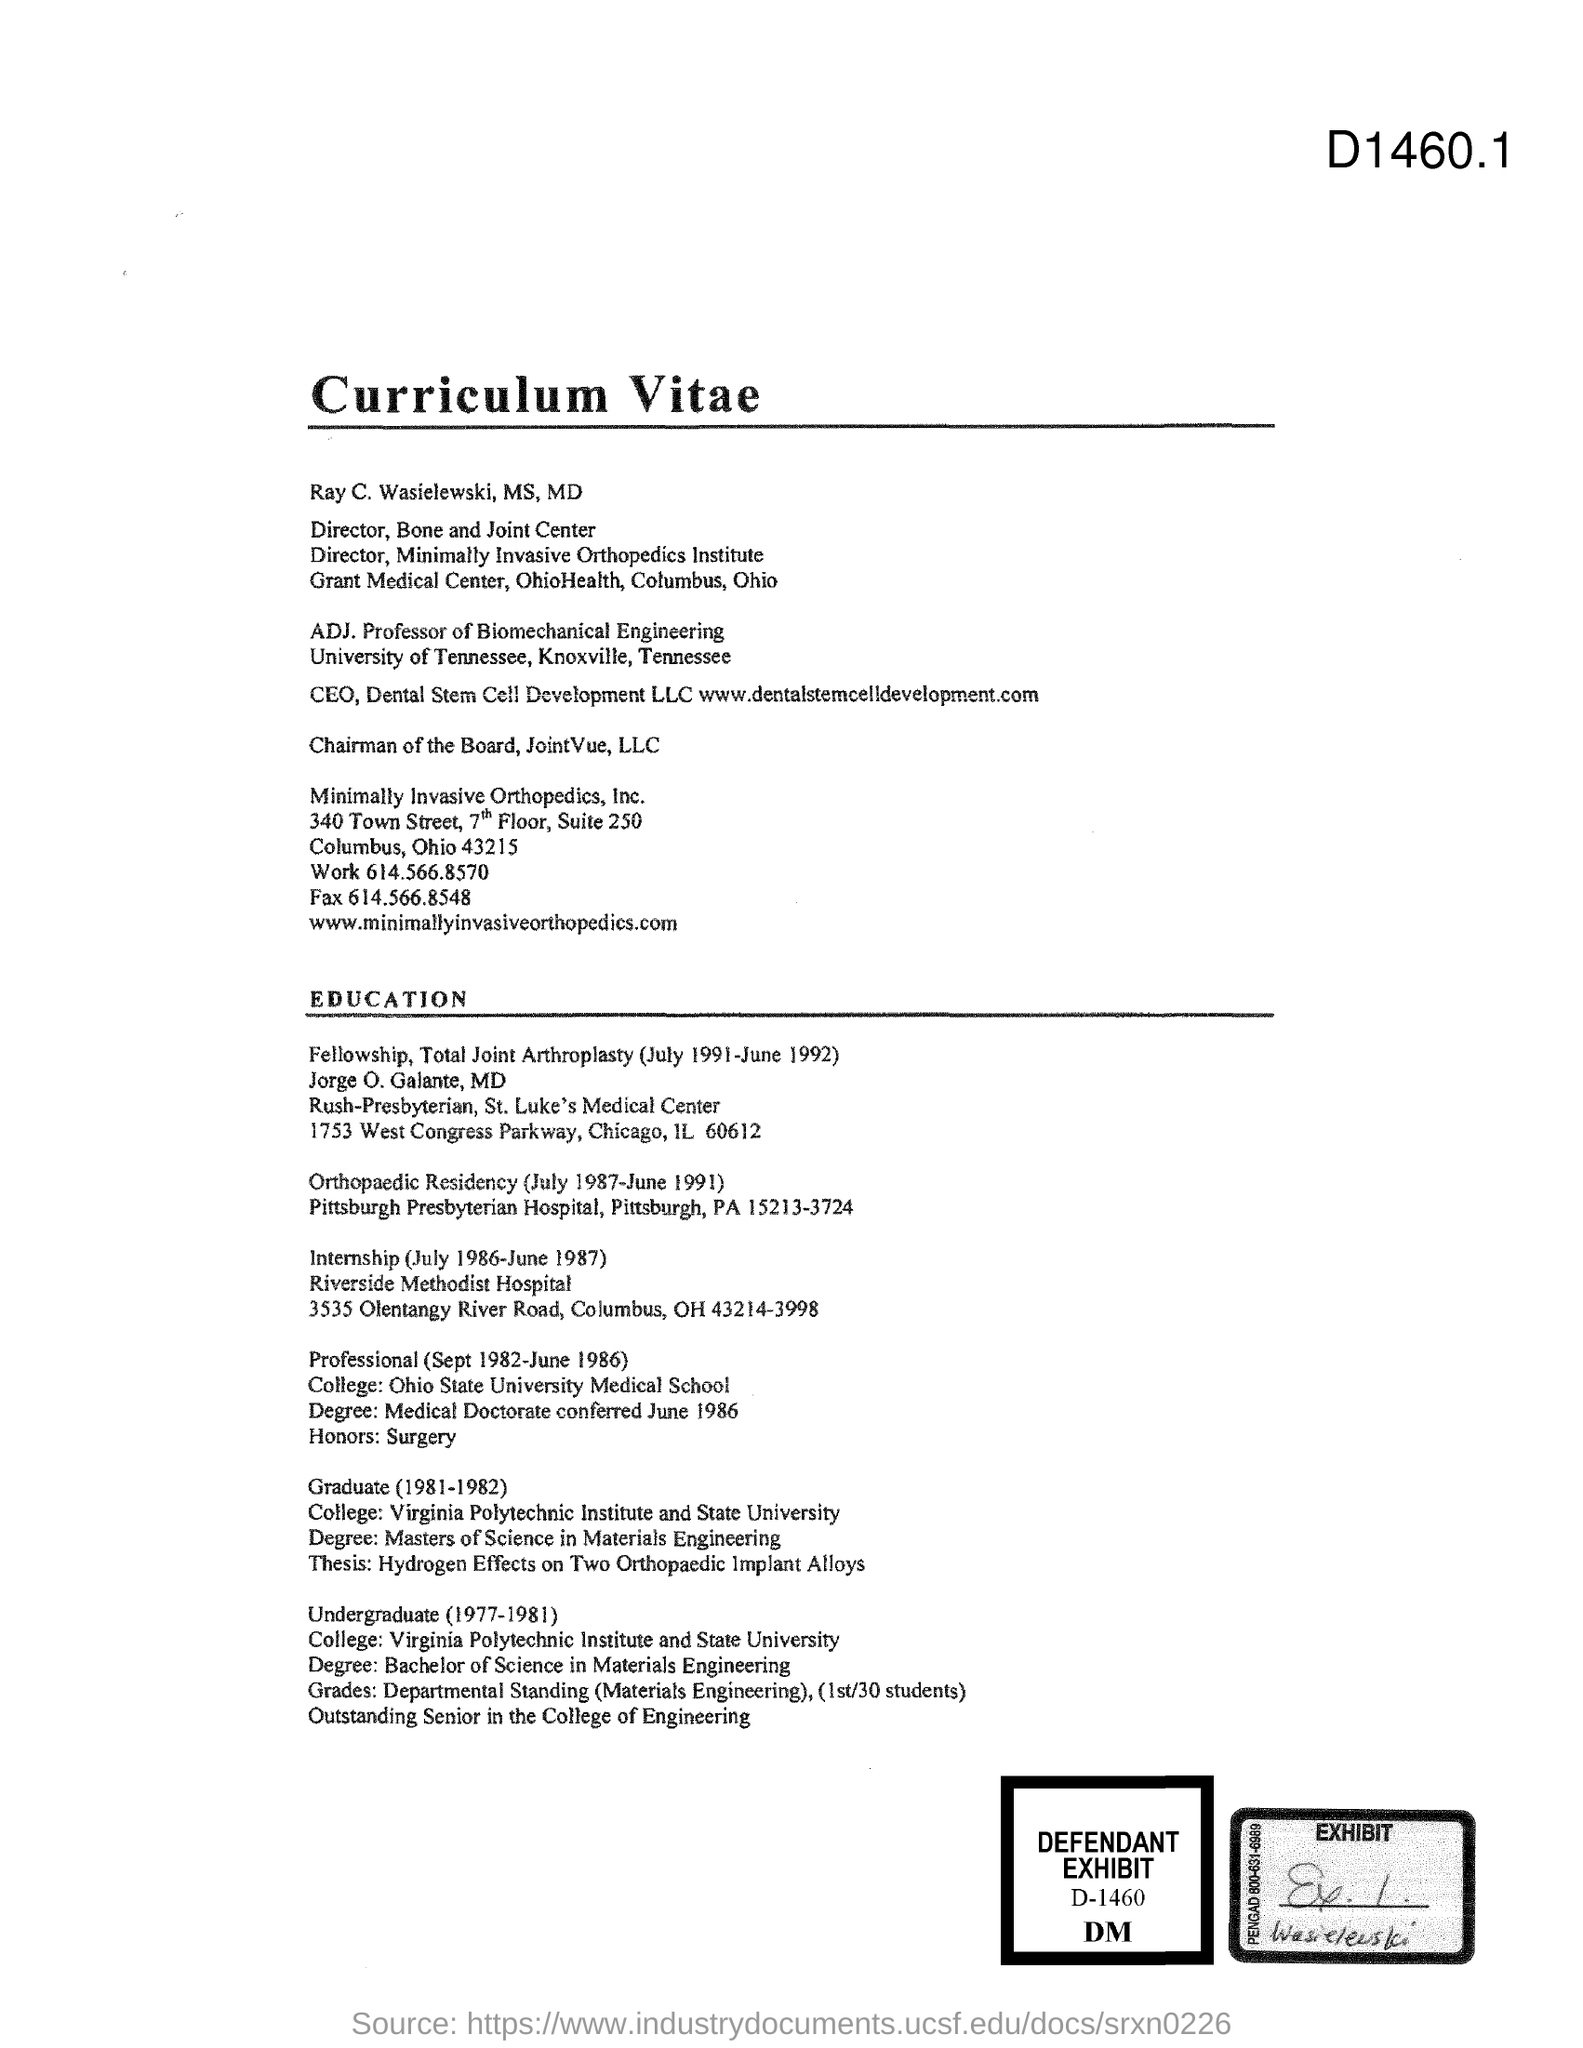What is the Title of the document?
Your answer should be compact. Curriculum vitae. 